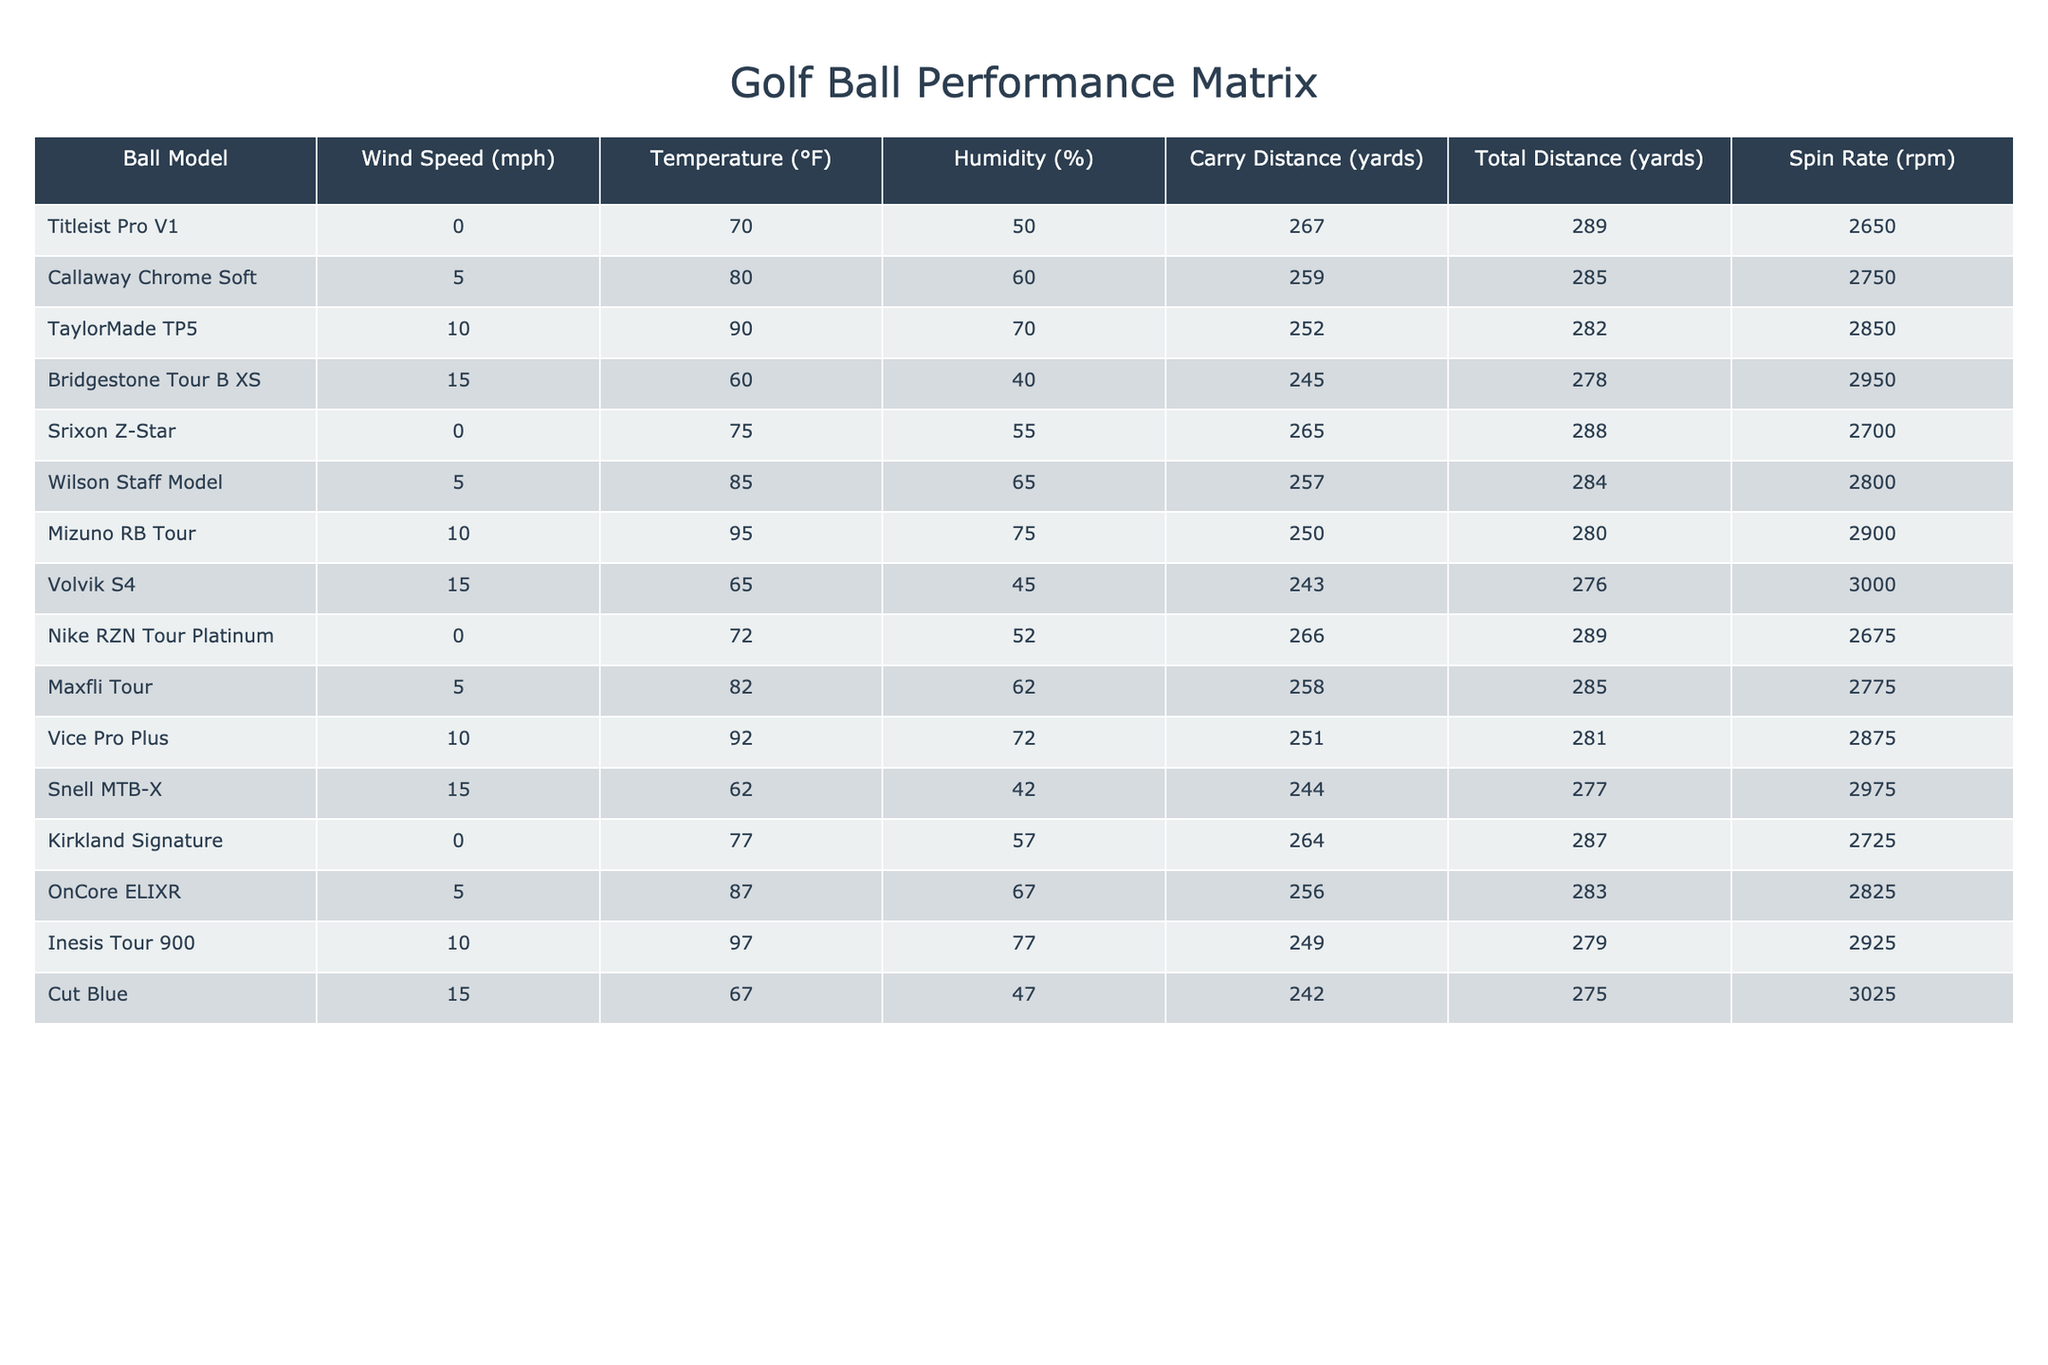What is the carry distance of the Titleist Pro V1? The carry distance for Titleist Pro V1 is found in the 'Carry Distance' column corresponding to its row, which shows a value of 267 yards.
Answer: 267 yards Which golf ball has the highest spin rate? By inspecting the 'Spin Rate' column, we see that the Volvik S4 has the highest value at 3000 rpm.
Answer: 3000 rpm What is the average carry distance across all balls tested? Sum the carry distances: (267 + 259 + 252 + 245 + 265 + 257 + 250 + 243 + 266 + 258 + 251 + 244 + 264 + 256 + 249 + 242) = 3960 yards. There are 16 balls, so the average is 3960 / 16 = 247.5 yards.
Answer: 247.5 yards Does wind speed affect the total distance achieved by golf balls? Comparing total distances at different wind speeds indicates variation; for example, the 0 mph wind has distances ranging from 264 to 266 yards, while at higher winds, distances seem reduced. A clear trend on the influence of wind is not established, so the answer is no.
Answer: No Which ball model performs best in terms of total distance in dry conditions (humidity below 50%)? Looking through the 'Humidity' column for values below 50%, we find that only the Bridgestone Tour B XS meets these criteria, with a total distance of 278 yards. Since it is the only ball fitting this condition, it performs best among the listed models.
Answer: Bridgestone Tour B XS What is the difference in carry distance between the Callaway Chrome Soft and the Snell MTB-X? The carry distance of Callaway Chrome Soft is 259 yards, while Snell MTB-X is at 244 yards. The difference is calculated as 259 - 244 = 15 yards.
Answer: 15 yards Is there a pattern in how temperature correlates with carry distance? Analyzing the temperature against carry distances shows that higher temperatures (like 90°F and 95°F) generally correspond to lower carry distances (252 yards and 250 yards, respectively). This illustrates a negative correlation between temperature and carry distance in this data set.
Answer: Yes Which two golf balls have total distances of exactly 285 yards? By scanning the 'Total Distance' column, we identify that both the Callaway Chrome Soft and Maxfli Tour have total distances of 285 yards.
Answer: Callaway Chrome Soft and Maxfli Tour Which golf ball has the lowest carry distance and at what weather condition? The lowest carry distance is for the Cut Blue, listed at 242 yards, recorded with 15 mph wind speed, 67°F temperature, and 47% humidity. This is the least distance among all conditions.
Answer: Cut Blue, 15 mph wind, 67°F, 47% humidity What can be inferred about the effect of humidity on spin rate? Inspecting the 'Spin Rate' with varying humidity levels suggests that higher humidity does not directly increase spin rates; for instance, the Snell MTB-X with 42% humidity shows a high spin rate of 2975 rpm compared to other values under higher humidity conditions. Thus, no clear inference can be drawn.
Answer: No clear inference How many golf balls have a carry distance greater than 250 yards? By checking the 'Carry Distance' column, the balls with carry distances over 250 yards are: Titleist Pro V1, Srixon Z-Star, Callaway Chrome Soft, Wilson Staff Model, and Nike RZN Tour Platinum, making a total of 5 balls.
Answer: 5 balls 